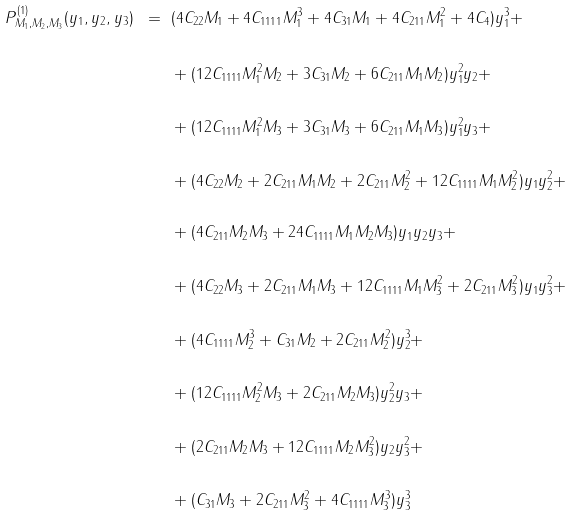Convert formula to latex. <formula><loc_0><loc_0><loc_500><loc_500>P ^ { ( 1 ) } _ { M _ { 1 } , M _ { 2 } , M _ { 3 } } ( y _ { 1 } , y _ { 2 } , y _ { 3 } ) \ = \ & ( 4 C _ { 2 2 } M _ { 1 } + 4 C _ { 1 1 1 1 } M _ { 1 } ^ { 3 } + 4 C _ { 3 1 } M _ { 1 } + 4 C _ { 2 1 1 } M _ { 1 } ^ { 2 } + 4 C _ { 4 } ) y _ { 1 } ^ { 3 } + \\ & \\ & + ( 1 2 C _ { 1 1 1 1 } M _ { 1 } ^ { 2 } M _ { 2 } + 3 C _ { 3 1 } M _ { 2 } + 6 C _ { 2 1 1 } M _ { 1 } M _ { 2 } ) y _ { 1 } ^ { 2 } y _ { 2 } + \\ & \\ & + ( 1 2 C _ { 1 1 1 1 } M _ { 1 } ^ { 2 } M _ { 3 } + 3 C _ { 3 1 } M _ { 3 } + 6 C _ { 2 1 1 } M _ { 1 } M _ { 3 } ) y _ { 1 } ^ { 2 } y _ { 3 } + \\ & \\ & + ( 4 C _ { 2 2 } M _ { 2 } + 2 C _ { 2 1 1 } M _ { 1 } M _ { 2 } + 2 C _ { 2 1 1 } M _ { 2 } ^ { 2 } + 1 2 C _ { 1 1 1 1 } M _ { 1 } M _ { 2 } ^ { 2 } ) y _ { 1 } y _ { 2 } ^ { 2 } + \\ & \\ & + ( 4 C _ { 2 1 1 } M _ { 2 } M _ { 3 } + 2 4 C _ { 1 1 1 1 } M _ { 1 } M _ { 2 } M _ { 3 } ) y _ { 1 } y _ { 2 } y _ { 3 } + \\ & \\ & + ( 4 C _ { 2 2 } M _ { 3 } + 2 C _ { 2 1 1 } M _ { 1 } M _ { 3 } + 1 2 C _ { 1 1 1 1 } M _ { 1 } M _ { 3 } ^ { 2 } + 2 C _ { 2 1 1 } M _ { 3 } ^ { 2 } ) y _ { 1 } y _ { 3 } ^ { 2 } + \\ & \\ & + ( 4 C _ { 1 1 1 1 } M _ { 2 } ^ { 3 } + C _ { 3 1 } M _ { 2 } + 2 C _ { 2 1 1 } M _ { 2 } ^ { 2 } ) y _ { 2 } ^ { 3 } + \\ & \\ & + ( 1 2 C _ { 1 1 1 1 } M _ { 2 } ^ { 2 } M _ { 3 } + 2 C _ { 2 1 1 } M _ { 2 } M _ { 3 } ) y _ { 2 } ^ { 2 } y _ { 3 } + \\ & \\ & + ( 2 C _ { 2 1 1 } M _ { 2 } M _ { 3 } + 1 2 C _ { 1 1 1 1 } M _ { 2 } M _ { 3 } ^ { 2 } ) y _ { 2 } y _ { 3 } ^ { 2 } + \\ & \\ & + ( C _ { 3 1 } M _ { 3 } + 2 C _ { 2 1 1 } M _ { 3 } ^ { 2 } + 4 C _ { 1 1 1 1 } M _ { 3 } ^ { 3 } ) y _ { 3 } ^ { 3 }</formula> 